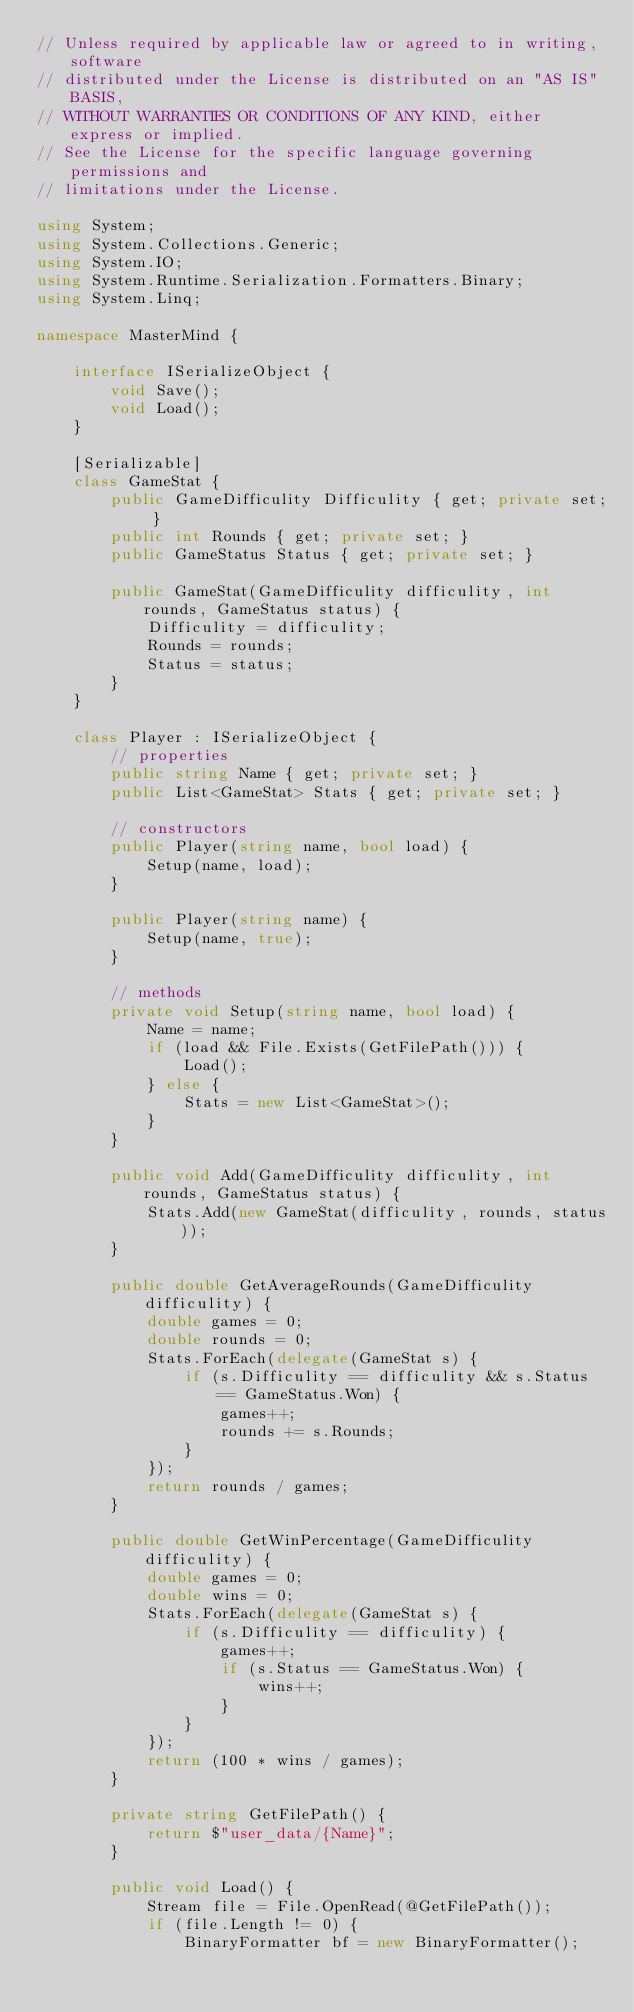<code> <loc_0><loc_0><loc_500><loc_500><_C#_>// Unless required by applicable law or agreed to in writing, software
// distributed under the License is distributed on an "AS IS" BASIS,
// WITHOUT WARRANTIES OR CONDITIONS OF ANY KIND, either express or implied.
// See the License for the specific language governing permissions and
// limitations under the License.

using System;
using System.Collections.Generic;
using System.IO;
using System.Runtime.Serialization.Formatters.Binary;
using System.Linq;

namespace MasterMind {

    interface ISerializeObject {
        void Save();
        void Load();
    }

    [Serializable]
    class GameStat {
        public GameDifficulity Difficulity { get; private set; }
        public int Rounds { get; private set; }
        public GameStatus Status { get; private set; }

        public GameStat(GameDifficulity difficulity, int rounds, GameStatus status) {
            Difficulity = difficulity;
            Rounds = rounds;
            Status = status;
        }
    }

    class Player : ISerializeObject {
        // properties
        public string Name { get; private set; }
        public List<GameStat> Stats { get; private set; }

        // constructors
        public Player(string name, bool load) {
            Setup(name, load);
        }

        public Player(string name) {
            Setup(name, true);
        }

        // methods
        private void Setup(string name, bool load) {
            Name = name;
            if (load && File.Exists(GetFilePath())) {
                Load();
            } else {
                Stats = new List<GameStat>();
            }
        }

        public void Add(GameDifficulity difficulity, int rounds, GameStatus status) {
            Stats.Add(new GameStat(difficulity, rounds, status));
        }

        public double GetAverageRounds(GameDifficulity difficulity) {
            double games = 0;
            double rounds = 0;
            Stats.ForEach(delegate(GameStat s) {
                if (s.Difficulity == difficulity && s.Status == GameStatus.Won) {
                    games++;
                    rounds += s.Rounds;
                }
            });
            return rounds / games;
        }

        public double GetWinPercentage(GameDifficulity difficulity) {
            double games = 0;
            double wins = 0;
            Stats.ForEach(delegate(GameStat s) {
                if (s.Difficulity == difficulity) {
                    games++;
                    if (s.Status == GameStatus.Won) {
                        wins++;
                    }
                }
            });
            return (100 * wins / games);
        }

        private string GetFilePath() {
            return $"user_data/{Name}";
        }

        public void Load() {
            Stream file = File.OpenRead(@GetFilePath());
            if (file.Length != 0) {
                BinaryFormatter bf = new BinaryFormatter();</code> 